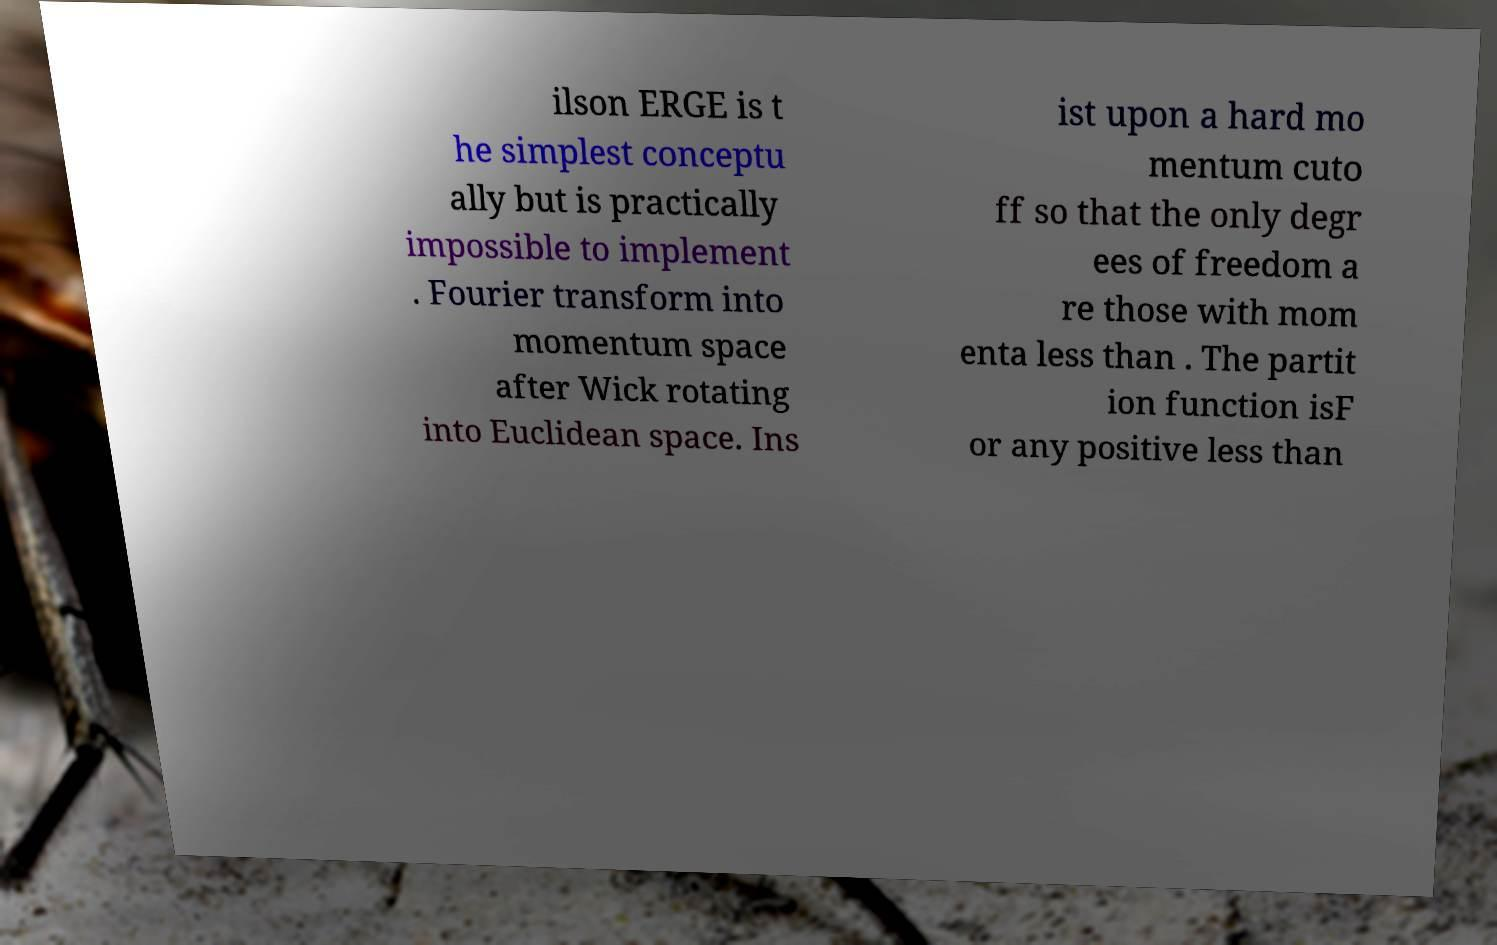For documentation purposes, I need the text within this image transcribed. Could you provide that? ilson ERGE is t he simplest conceptu ally but is practically impossible to implement . Fourier transform into momentum space after Wick rotating into Euclidean space. Ins ist upon a hard mo mentum cuto ff so that the only degr ees of freedom a re those with mom enta less than . The partit ion function isF or any positive less than 